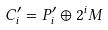Convert formula to latex. <formula><loc_0><loc_0><loc_500><loc_500>C _ { i } ^ { \prime } = P _ { i } ^ { \prime } \oplus 2 ^ { i } M</formula> 